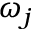<formula> <loc_0><loc_0><loc_500><loc_500>\omega _ { j }</formula> 